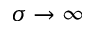<formula> <loc_0><loc_0><loc_500><loc_500>\sigma \to \infty</formula> 